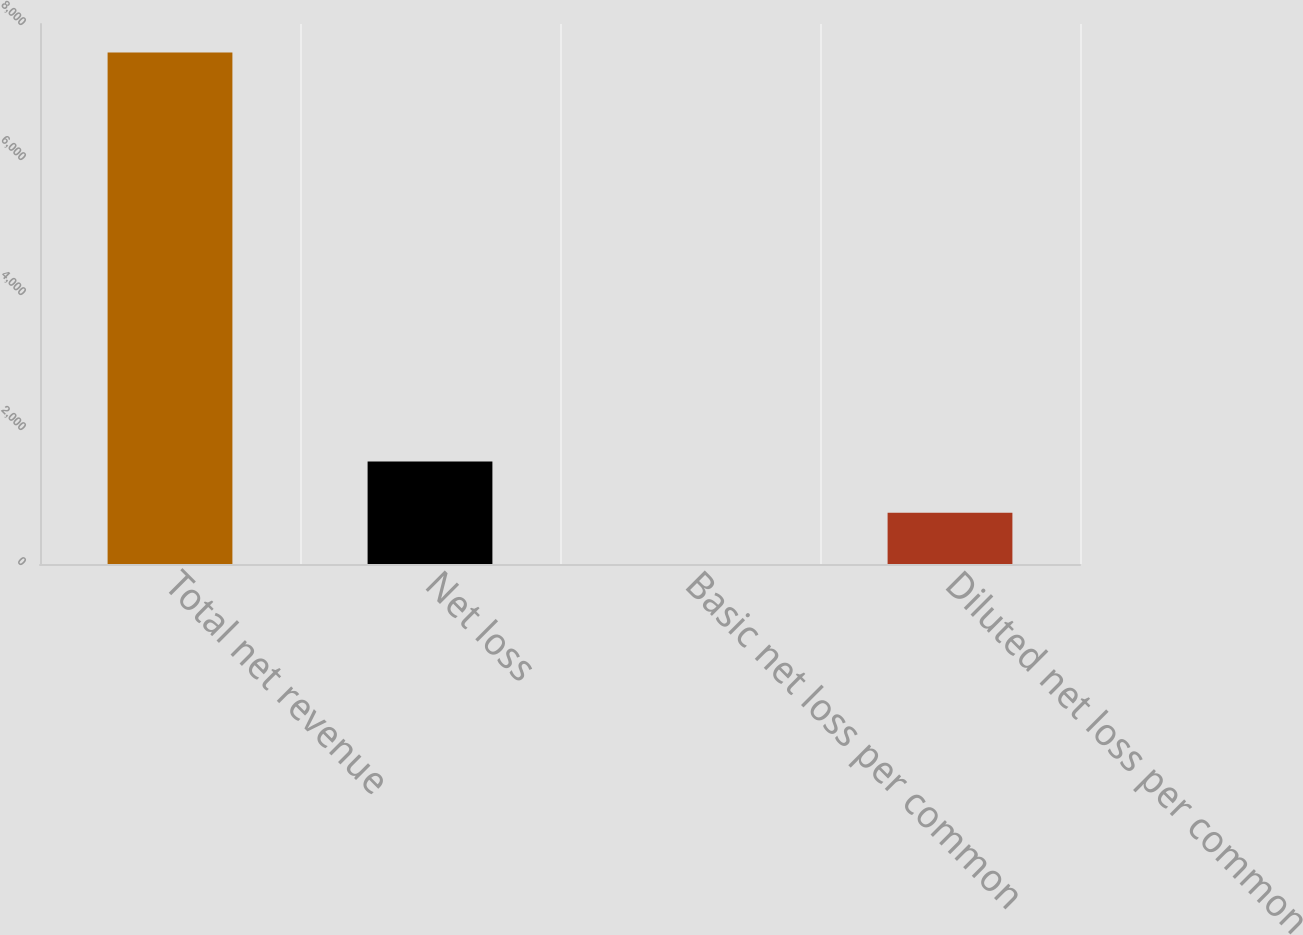<chart> <loc_0><loc_0><loc_500><loc_500><bar_chart><fcel>Total net revenue<fcel>Net loss<fcel>Basic net loss per common<fcel>Diluted net loss per common<nl><fcel>7579<fcel>1516.87<fcel>1.33<fcel>759.1<nl></chart> 